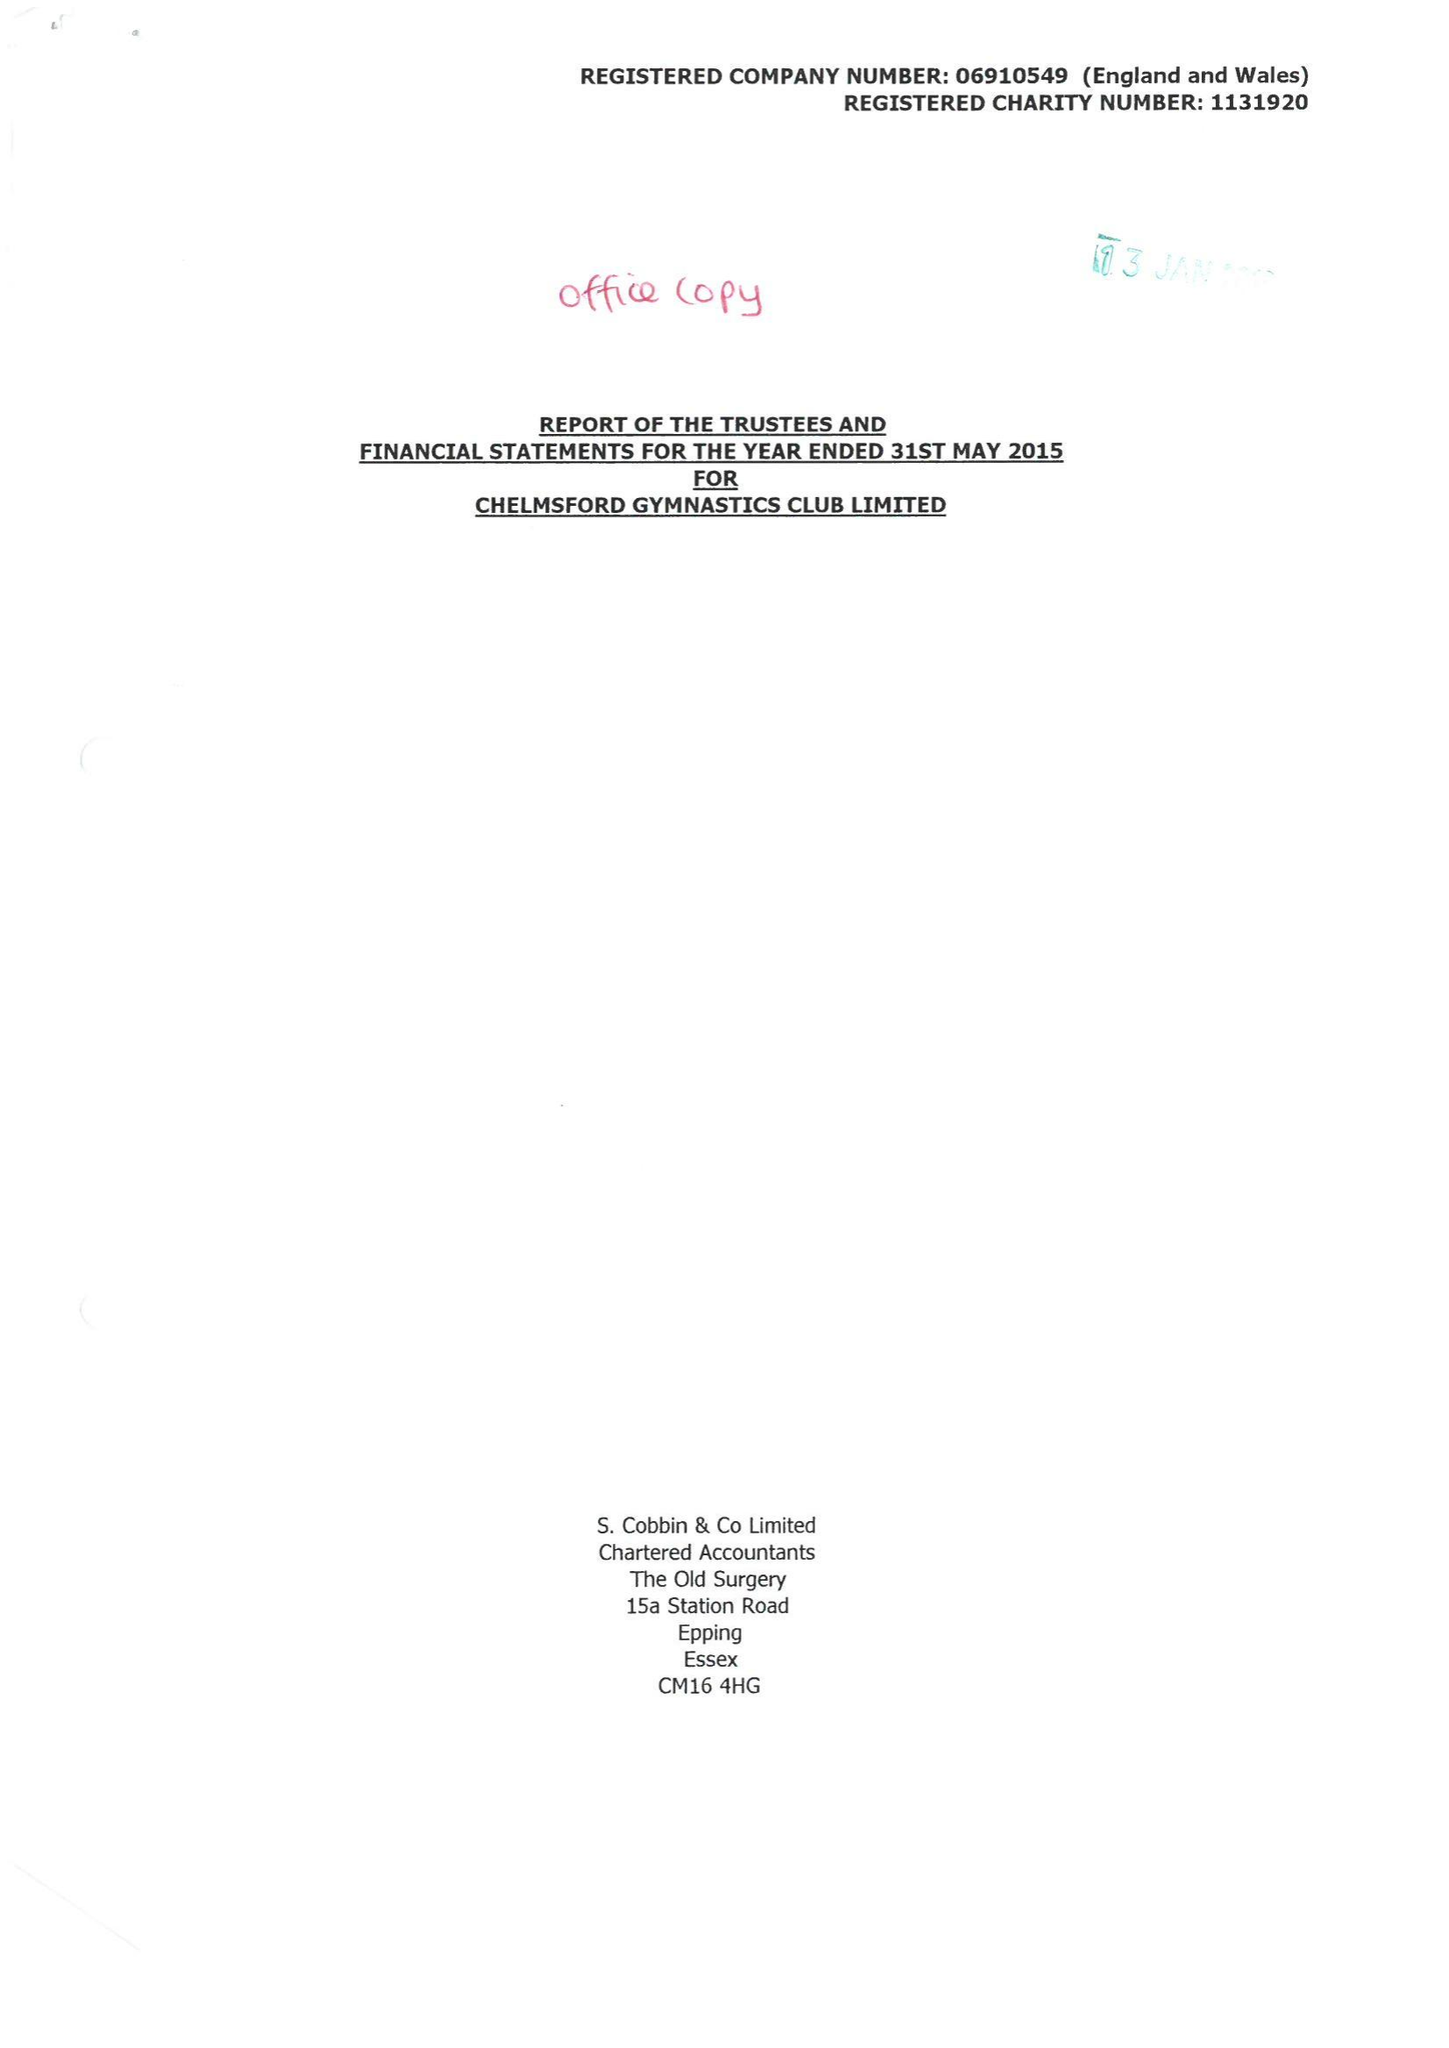What is the value for the income_annually_in_british_pounds?
Answer the question using a single word or phrase. 325739.00 